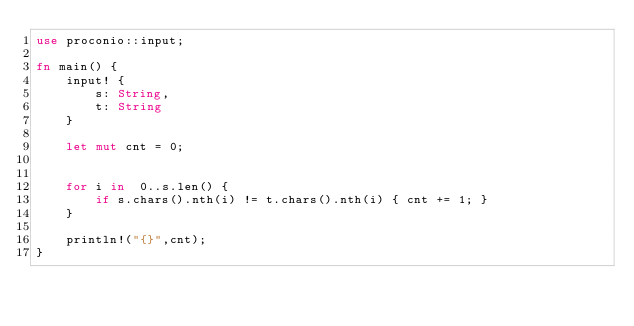<code> <loc_0><loc_0><loc_500><loc_500><_Rust_>use proconio::input;

fn main() {
    input! {
        s: String,
        t: String
    }

    let mut cnt = 0;


    for i in  0..s.len() {
        if s.chars().nth(i) != t.chars().nth(i) { cnt += 1; }
    }

    println!("{}",cnt);
}
</code> 